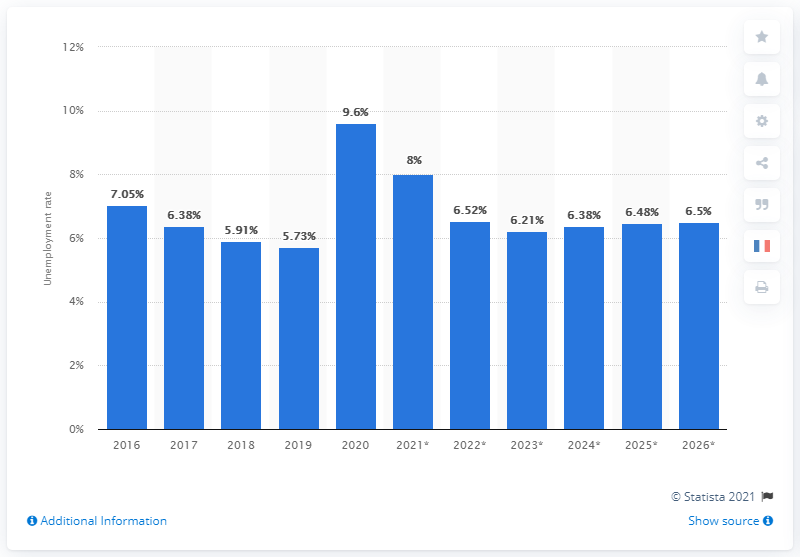Mention a couple of crucial points in this snapshot. In 2020, the unemployment rate in Canada came to an end. 